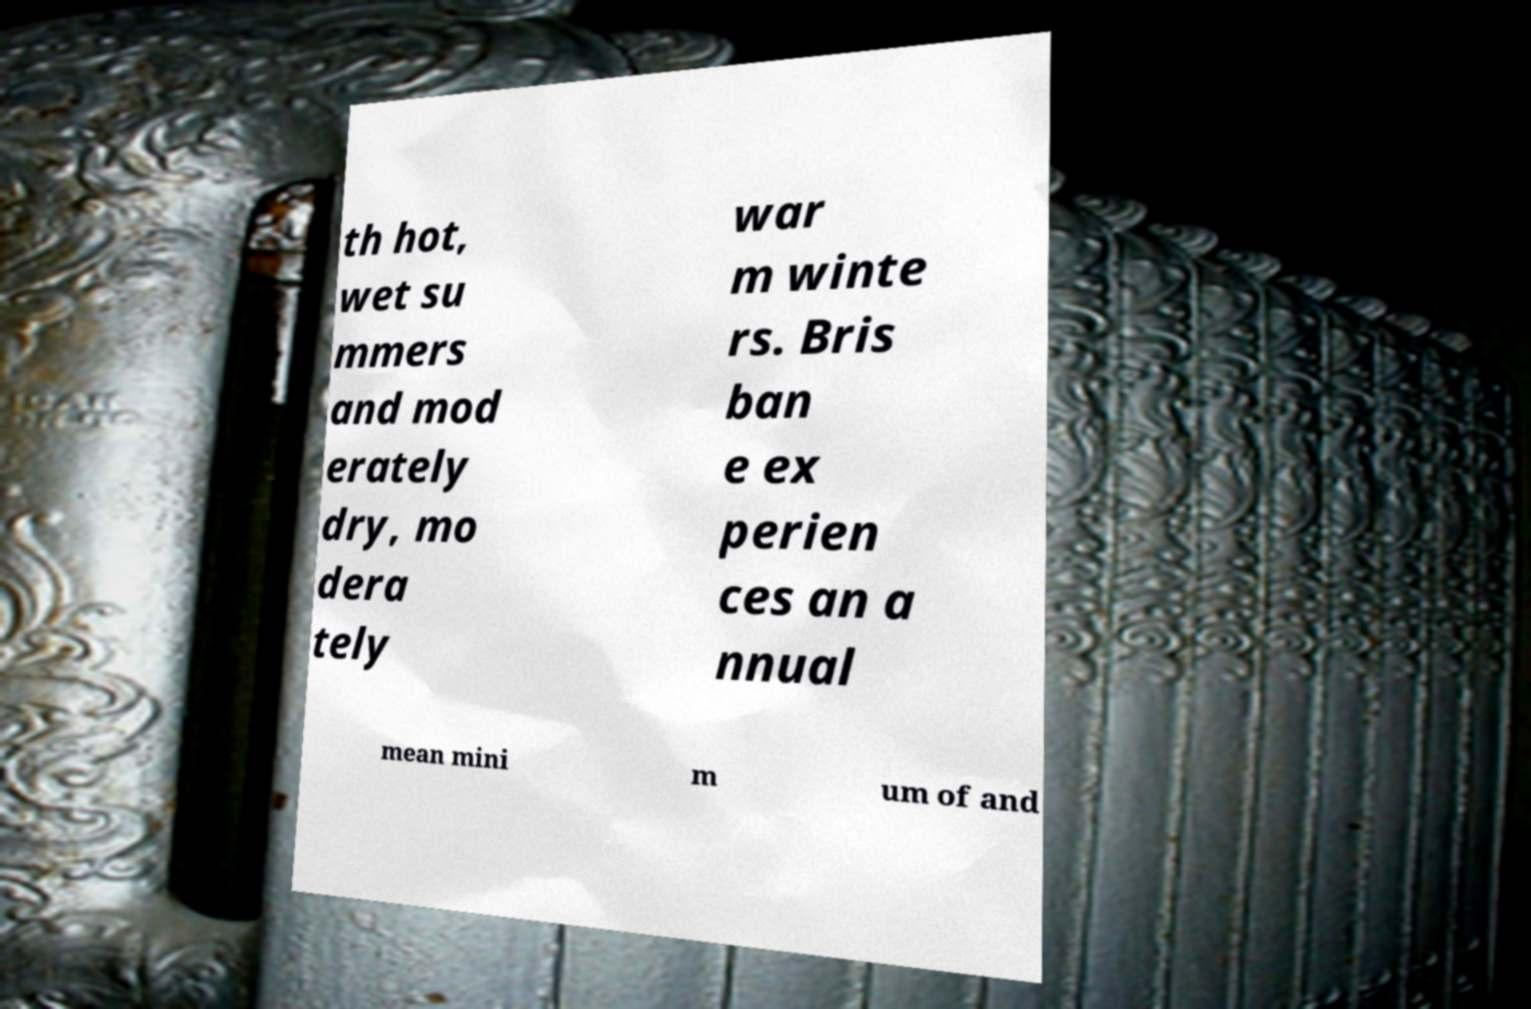Could you assist in decoding the text presented in this image and type it out clearly? th hot, wet su mmers and mod erately dry, mo dera tely war m winte rs. Bris ban e ex perien ces an a nnual mean mini m um of and 